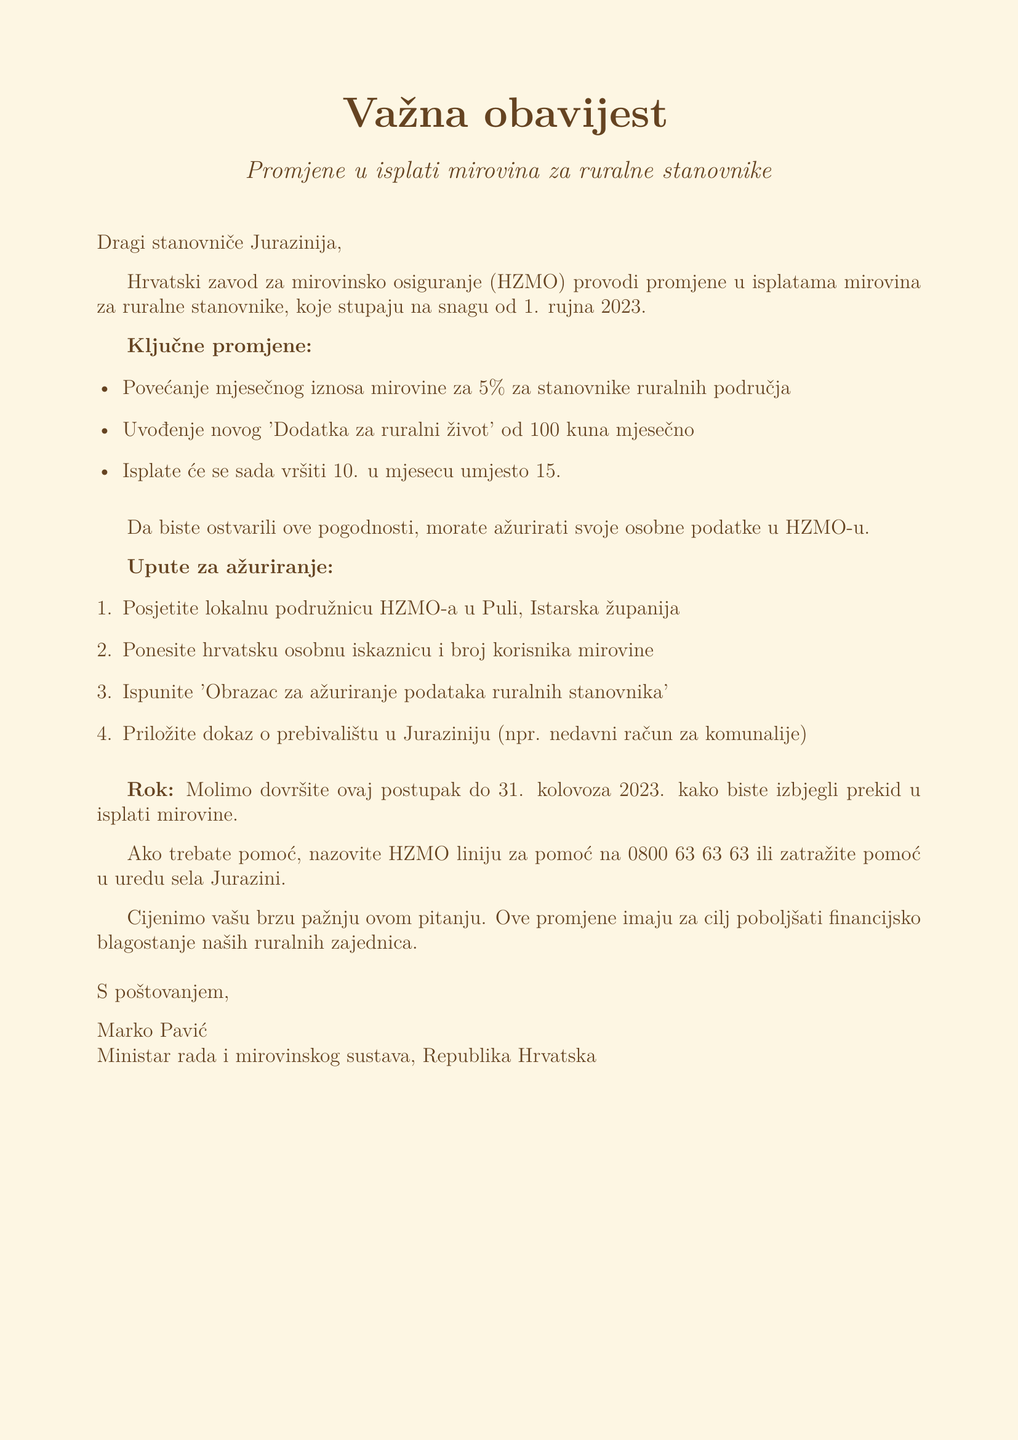What is the effective date of the pension payment changes? The effective date is specified in the document as 1 September 2023.
Answer: 1 September 2023 What is the percentage increase in the monthly pension amount? The document states that there is a 5% increase in the monthly pension amount for rural residents.
Answer: 5% What is the amount of the new 'Rural Living Supplement'? The document mentions the new supplement amount is 100 kuna per month.
Answer: 100 kuna What is the new payment date for pensions? The document indicates that payments will now be made on the 10th of each month instead of the 15th.
Answer: 10th What must residents bring to the HZMO office to update their information? Residents must bring their Croatian ID card and pension beneficiary number as stated in the instructions.
Answer: Croatian ID card and pension beneficiary number What is the deadline for updating personal information? The deadline is specified as 31 August 2023 in the document.
Answer: 31 August 2023 Where should residents go to update their information? The document states residents should visit the local HZMO office in Pula, Istria County.
Answer: local HZMO office in Pula Who can residents contact for assistance? Residents can contact the HZMO helpline or ask for assistance at the Jurazini village office as detailed in the document.
Answer: HZMO helpline or Jurazini village office 